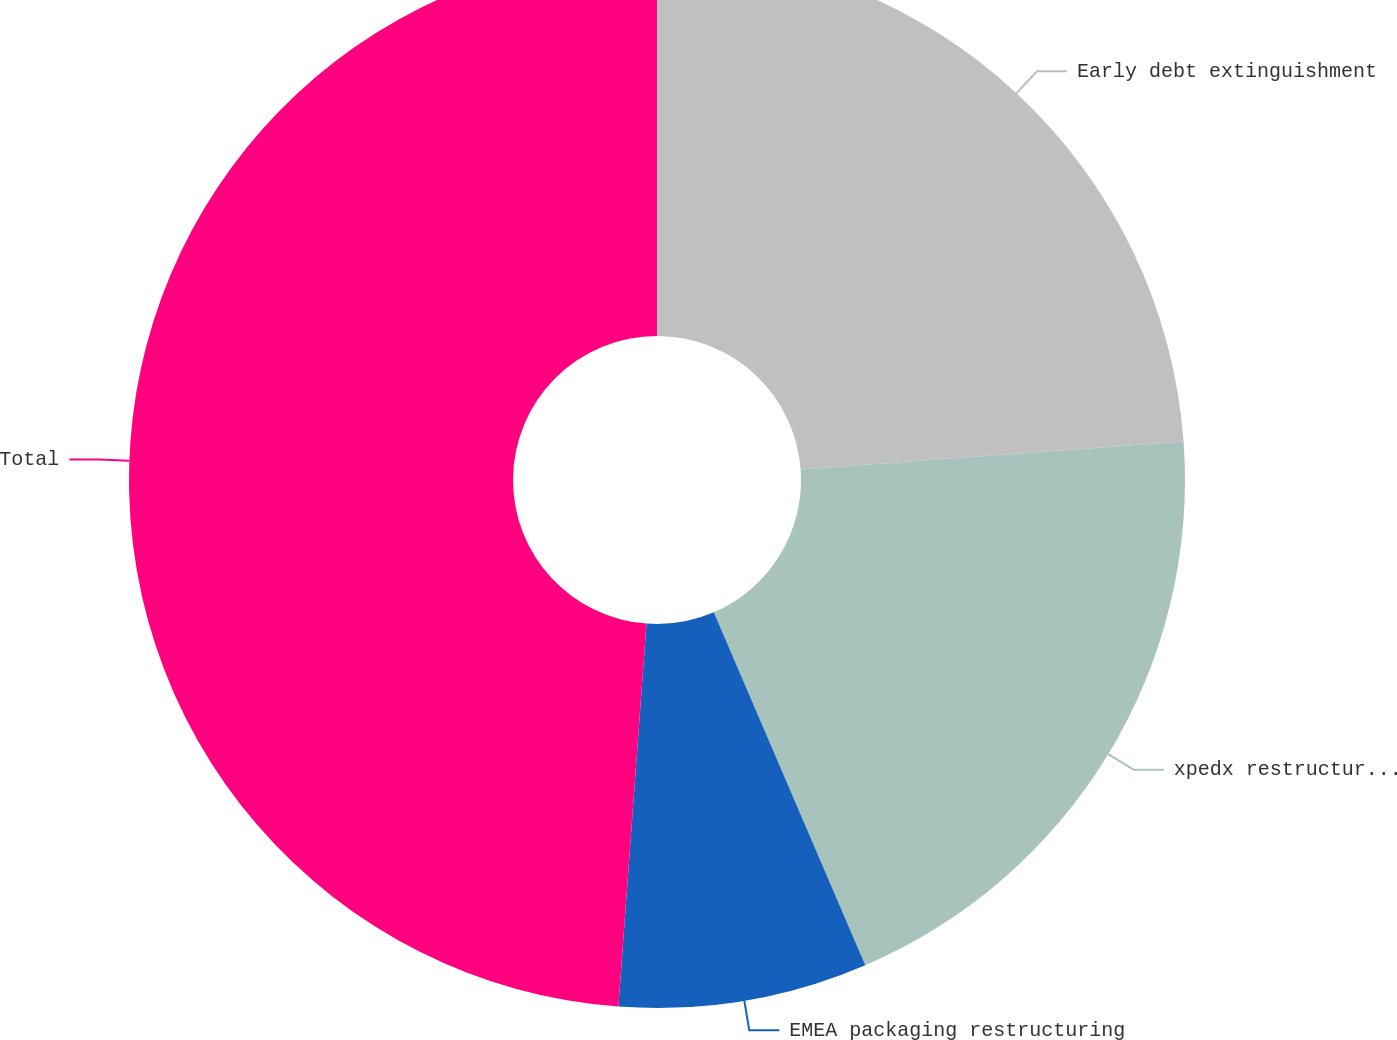Convert chart. <chart><loc_0><loc_0><loc_500><loc_500><pie_chart><fcel>Early debt extinguishment<fcel>xpedx restructuring (a)<fcel>EMEA packaging restructuring<fcel>Total<nl><fcel>23.84%<fcel>19.71%<fcel>7.62%<fcel>48.84%<nl></chart> 